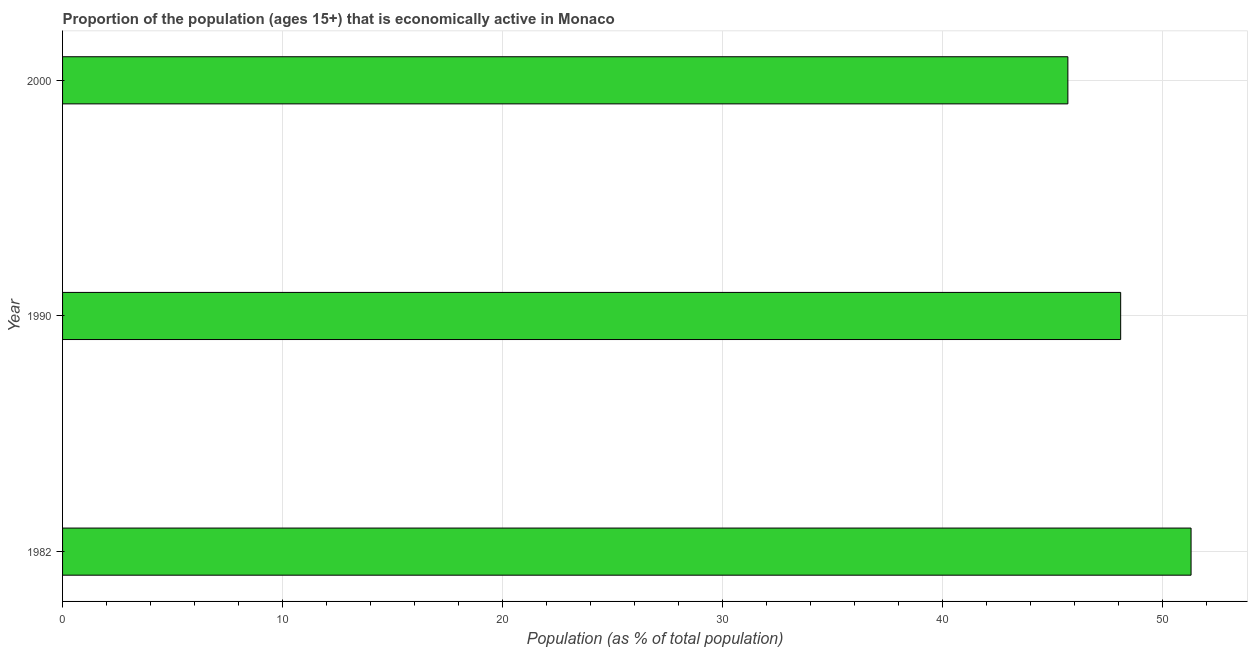Does the graph contain any zero values?
Provide a succinct answer. No. What is the title of the graph?
Give a very brief answer. Proportion of the population (ages 15+) that is economically active in Monaco. What is the label or title of the X-axis?
Provide a succinct answer. Population (as % of total population). What is the percentage of economically active population in 1990?
Your answer should be compact. 48.1. Across all years, what is the maximum percentage of economically active population?
Keep it short and to the point. 51.3. Across all years, what is the minimum percentage of economically active population?
Offer a terse response. 45.7. In which year was the percentage of economically active population maximum?
Your answer should be compact. 1982. In which year was the percentage of economically active population minimum?
Your answer should be very brief. 2000. What is the sum of the percentage of economically active population?
Your response must be concise. 145.1. What is the average percentage of economically active population per year?
Offer a terse response. 48.37. What is the median percentage of economically active population?
Make the answer very short. 48.1. Do a majority of the years between 1990 and 1982 (inclusive) have percentage of economically active population greater than 12 %?
Offer a very short reply. No. What is the ratio of the percentage of economically active population in 1990 to that in 2000?
Provide a succinct answer. 1.05. What is the difference between the highest and the second highest percentage of economically active population?
Make the answer very short. 3.2. Is the sum of the percentage of economically active population in 1982 and 1990 greater than the maximum percentage of economically active population across all years?
Provide a short and direct response. Yes. In how many years, is the percentage of economically active population greater than the average percentage of economically active population taken over all years?
Provide a short and direct response. 1. Are the values on the major ticks of X-axis written in scientific E-notation?
Provide a succinct answer. No. What is the Population (as % of total population) of 1982?
Provide a short and direct response. 51.3. What is the Population (as % of total population) of 1990?
Your answer should be very brief. 48.1. What is the Population (as % of total population) in 2000?
Your response must be concise. 45.7. What is the difference between the Population (as % of total population) in 1982 and 1990?
Offer a terse response. 3.2. What is the difference between the Population (as % of total population) in 1990 and 2000?
Keep it short and to the point. 2.4. What is the ratio of the Population (as % of total population) in 1982 to that in 1990?
Your answer should be compact. 1.07. What is the ratio of the Population (as % of total population) in 1982 to that in 2000?
Ensure brevity in your answer.  1.12. What is the ratio of the Population (as % of total population) in 1990 to that in 2000?
Your response must be concise. 1.05. 